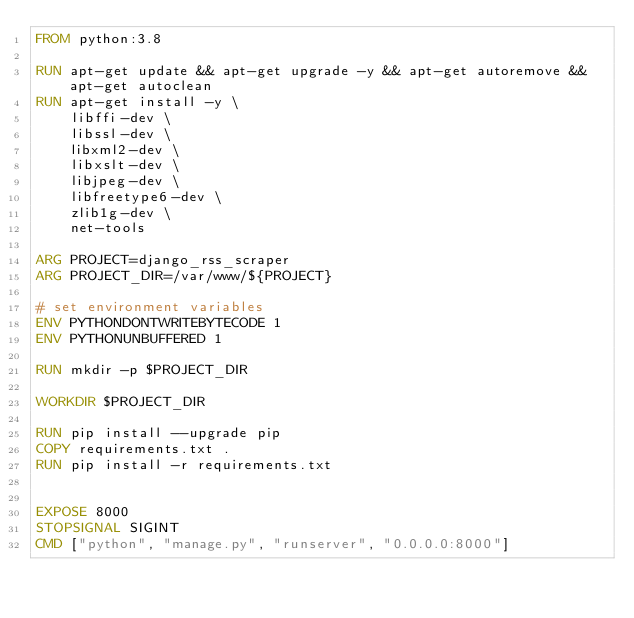<code> <loc_0><loc_0><loc_500><loc_500><_Dockerfile_>FROM python:3.8

RUN apt-get update && apt-get upgrade -y && apt-get autoremove && apt-get autoclean
RUN apt-get install -y \
    libffi-dev \
    libssl-dev \
    libxml2-dev \
    libxslt-dev \
    libjpeg-dev \
    libfreetype6-dev \
    zlib1g-dev \
    net-tools

ARG PROJECT=django_rss_scraper
ARG PROJECT_DIR=/var/www/${PROJECT}

# set environment variables
ENV PYTHONDONTWRITEBYTECODE 1
ENV PYTHONUNBUFFERED 1

RUN mkdir -p $PROJECT_DIR

WORKDIR $PROJECT_DIR

RUN pip install --upgrade pip
COPY requirements.txt .
RUN pip install -r requirements.txt


EXPOSE 8000
STOPSIGNAL SIGINT
CMD ["python", "manage.py", "runserver", "0.0.0.0:8000"]</code> 